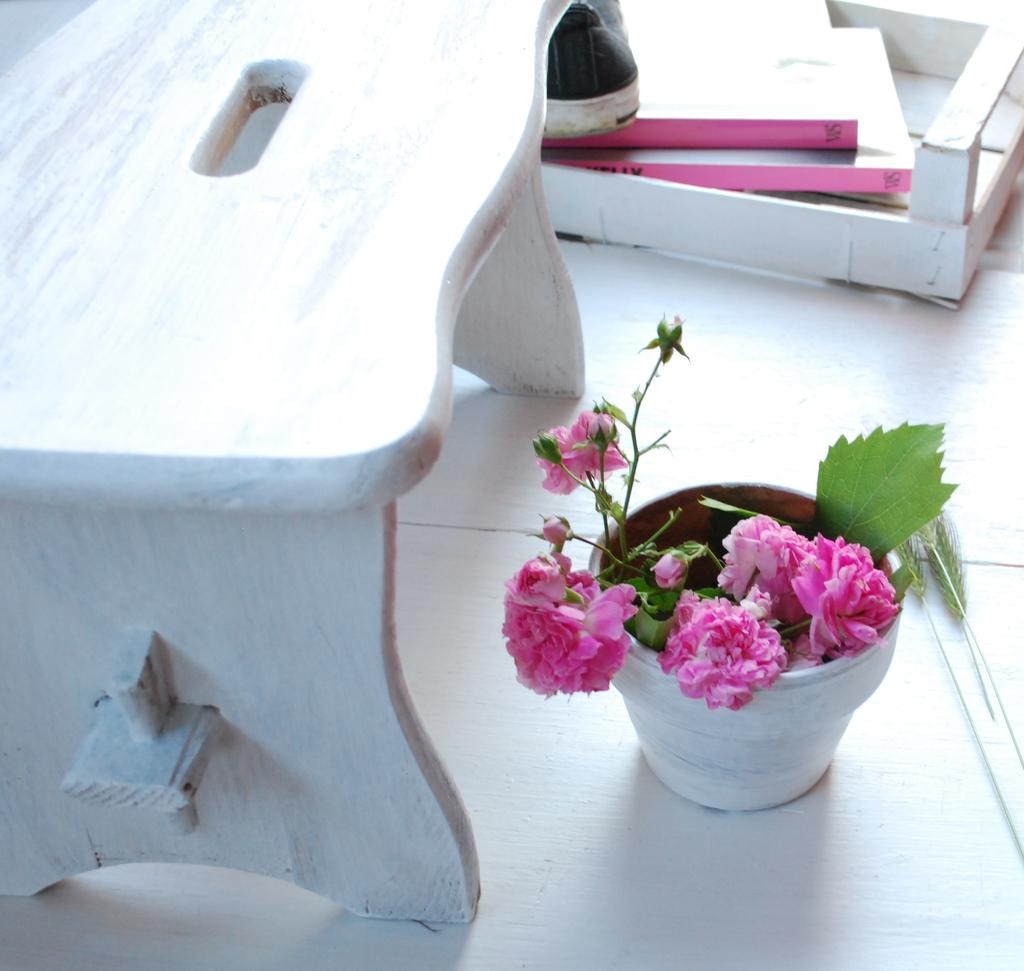What type of seating is visible in the image? There is a bench in the image. What is the plant in the image contained in? The plant in the image is in a vase. What time does the clock show in the image? There is no clock present in the image. What type of toad can be seen sitting on the bench in the image? There is no toad present in the image. 